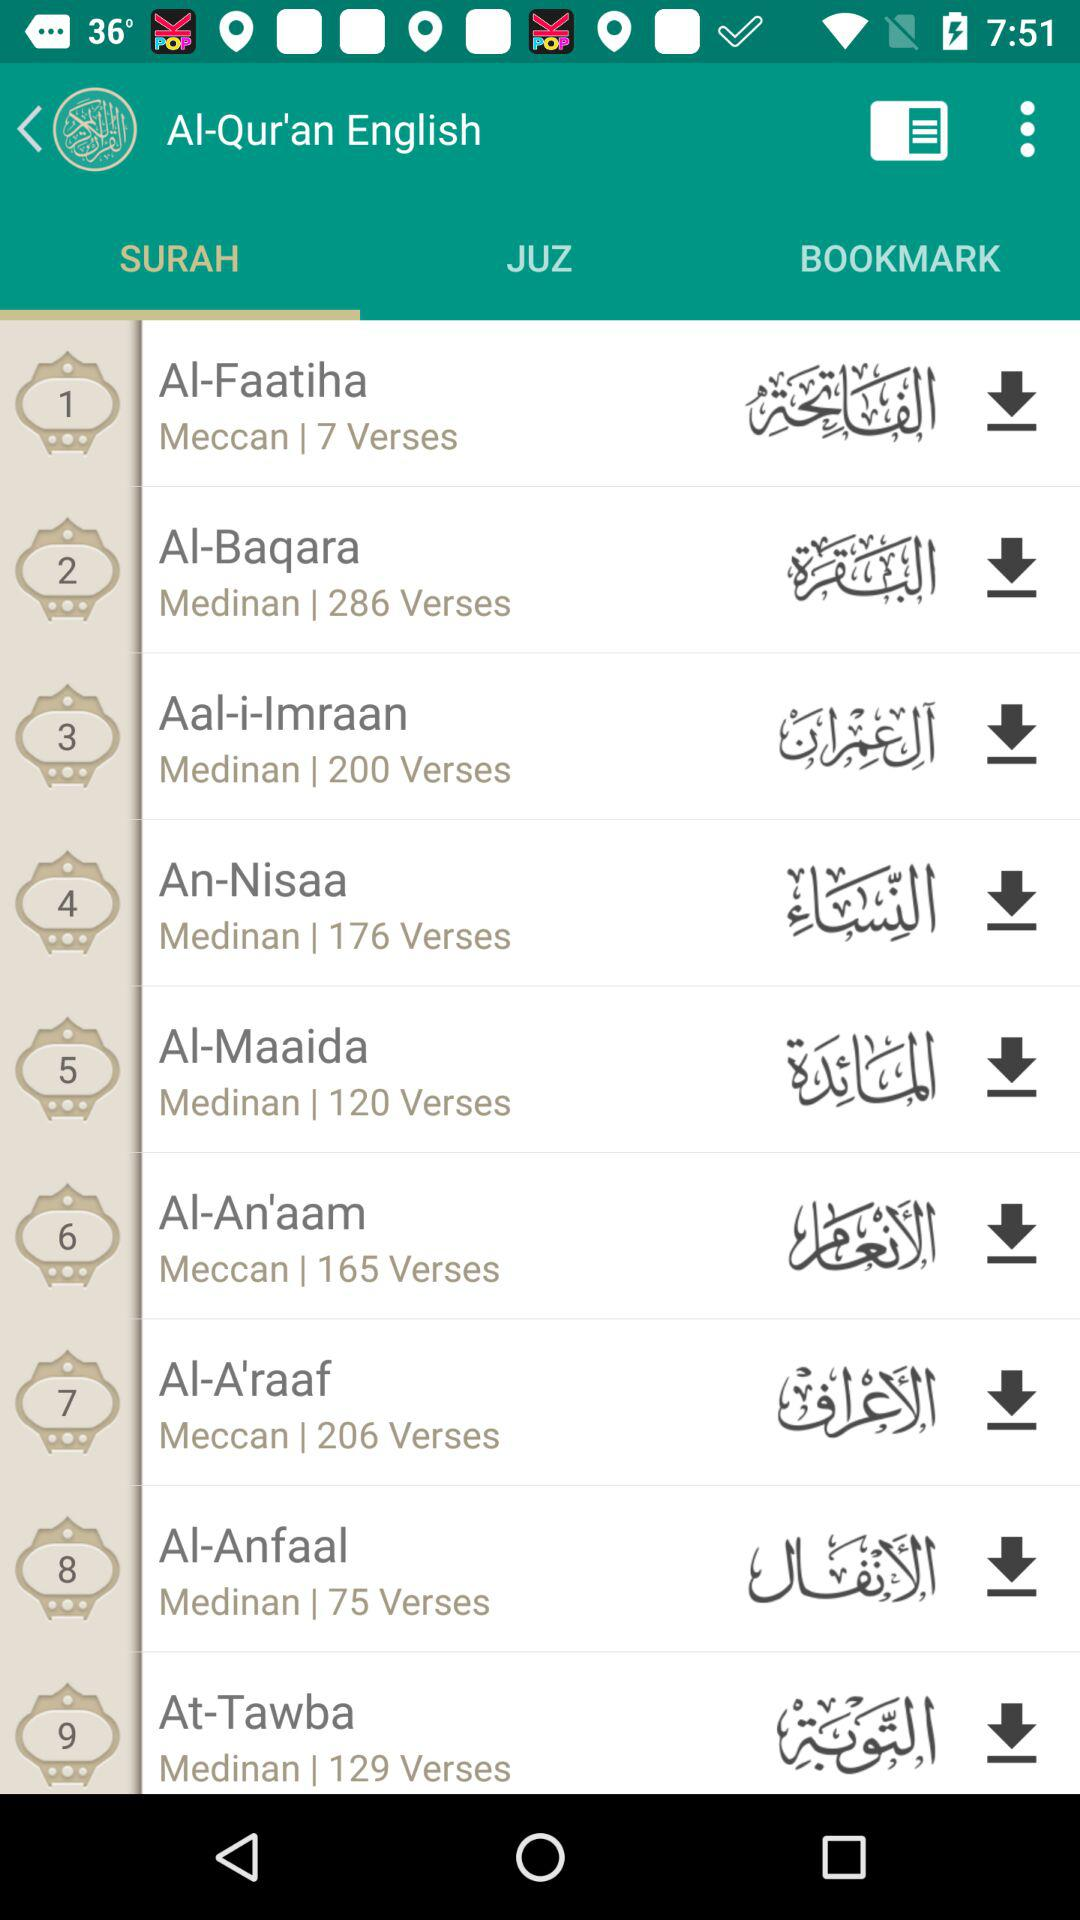Which surah has more verses, Al-Faatiha or Al-Baqara?
Answer the question using a single word or phrase. Al-Baqara 